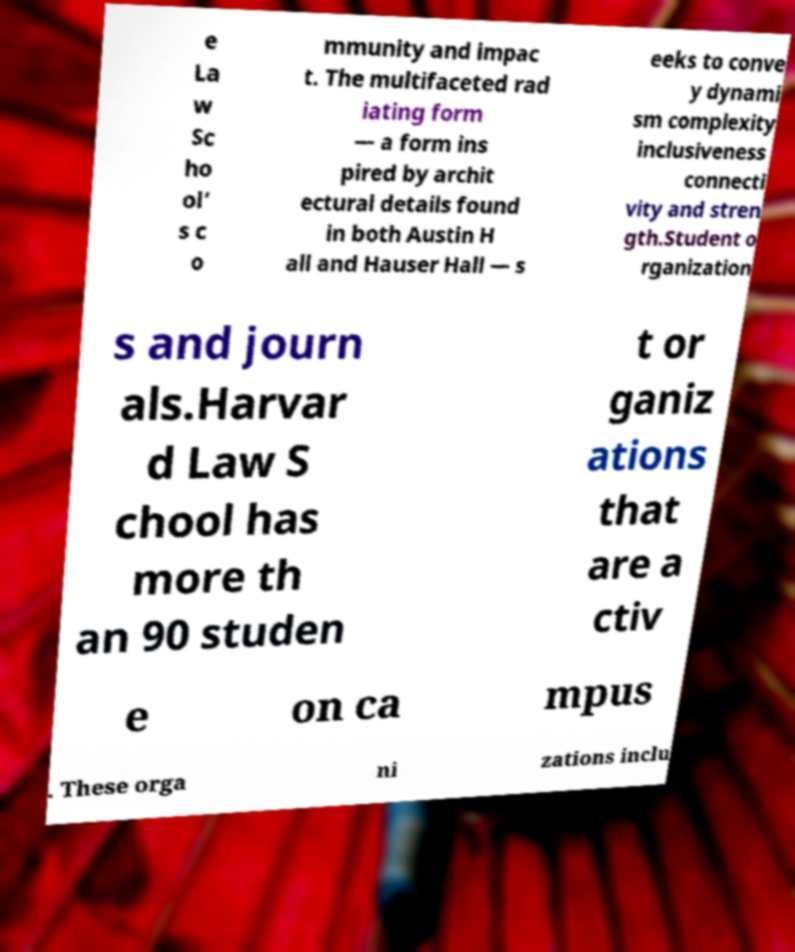There's text embedded in this image that I need extracted. Can you transcribe it verbatim? e La w Sc ho ol’ s c o mmunity and impac t. The multifaceted rad iating form — a form ins pired by archit ectural details found in both Austin H all and Hauser Hall — s eeks to conve y dynami sm complexity inclusiveness connecti vity and stren gth.Student o rganization s and journ als.Harvar d Law S chool has more th an 90 studen t or ganiz ations that are a ctiv e on ca mpus . These orga ni zations inclu 